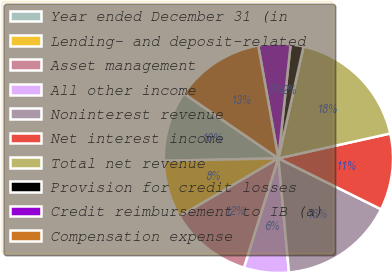Convert chart to OTSL. <chart><loc_0><loc_0><loc_500><loc_500><pie_chart><fcel>Year ended December 31 (in<fcel>Lending- and deposit-related<fcel>Asset management<fcel>All other income<fcel>Noninterest revenue<fcel>Net interest income<fcel>Total net revenue<fcel>Provision for credit losses<fcel>Credit reimbursement to IB (a)<fcel>Compensation expense<nl><fcel>9.91%<fcel>8.11%<fcel>11.71%<fcel>6.31%<fcel>16.2%<fcel>10.81%<fcel>18.0%<fcel>1.82%<fcel>4.52%<fcel>12.61%<nl></chart> 